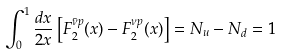<formula> <loc_0><loc_0><loc_500><loc_500>\int ^ { 1 } _ { 0 } \frac { d x } { 2 x } \left [ F ^ { \bar { \nu } p } _ { 2 } ( x ) - F ^ { \nu p } _ { 2 } ( x ) \right ] = N _ { u } - N _ { d } = 1 \,</formula> 